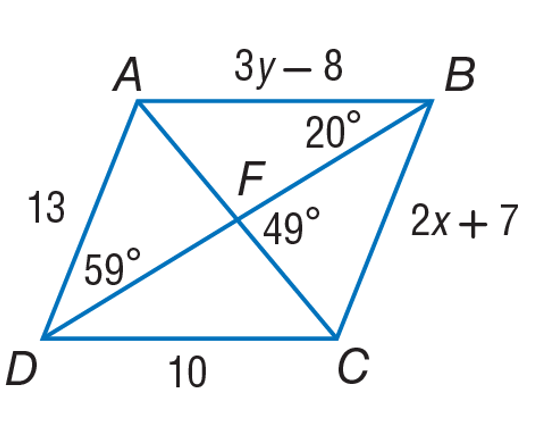Answer the mathemtical geometry problem and directly provide the correct option letter.
Question: Use parallelogram A B C D to find x.
Choices: A: 3 B: 6 C: 10 D: 13 A 